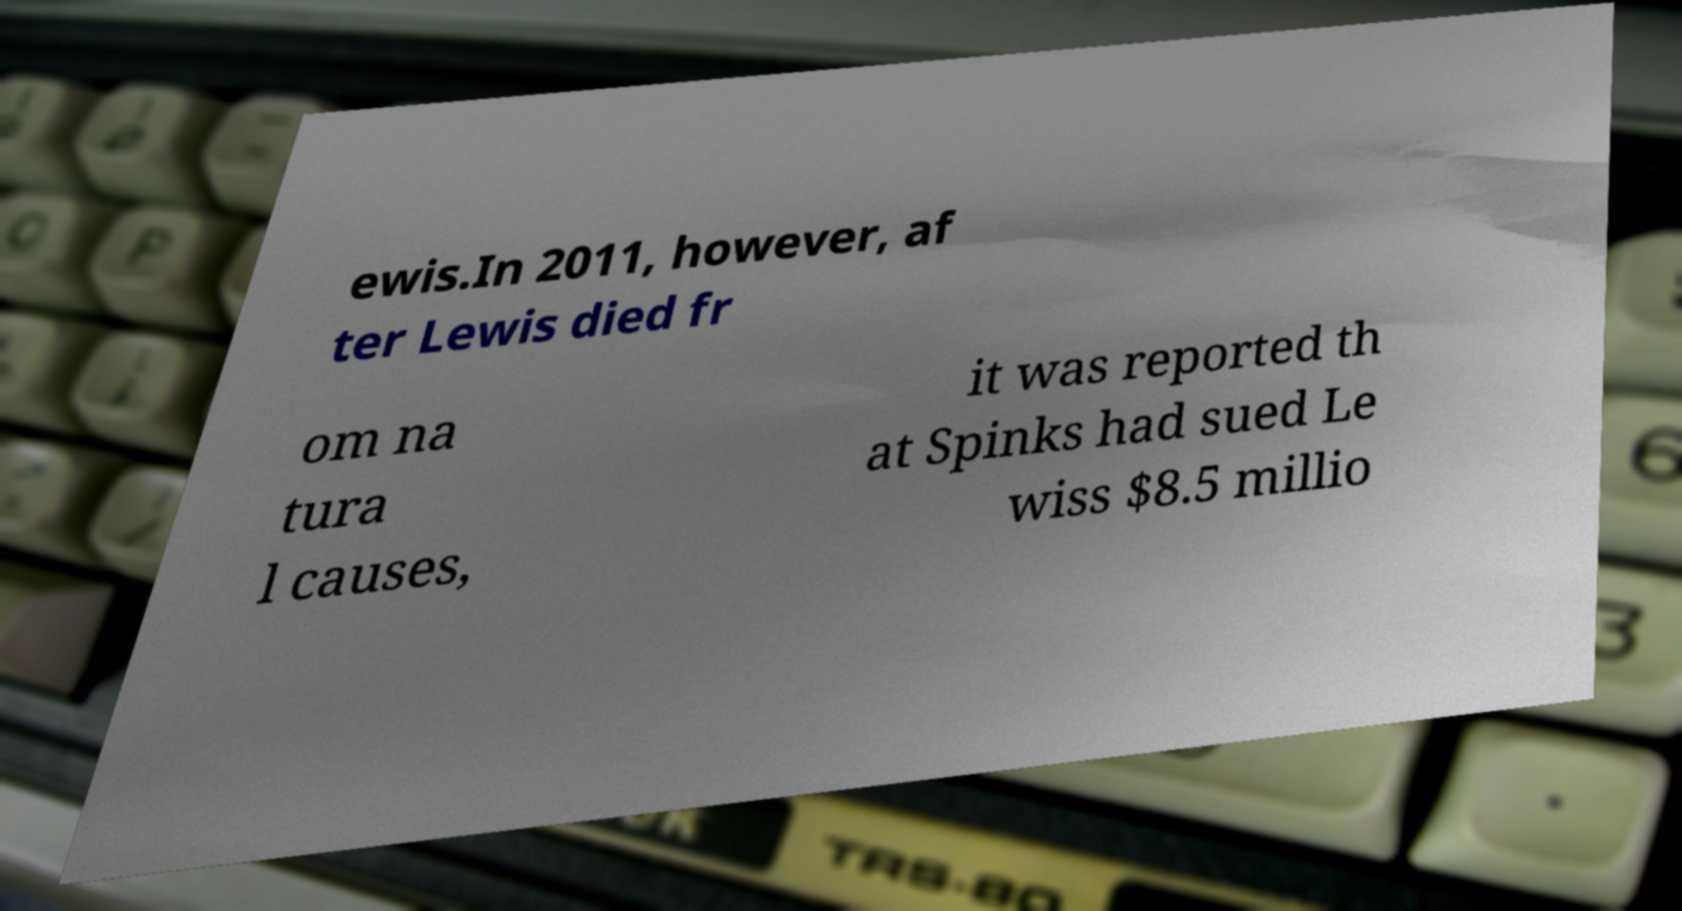There's text embedded in this image that I need extracted. Can you transcribe it verbatim? ewis.In 2011, however, af ter Lewis died fr om na tura l causes, it was reported th at Spinks had sued Le wiss $8.5 millio 